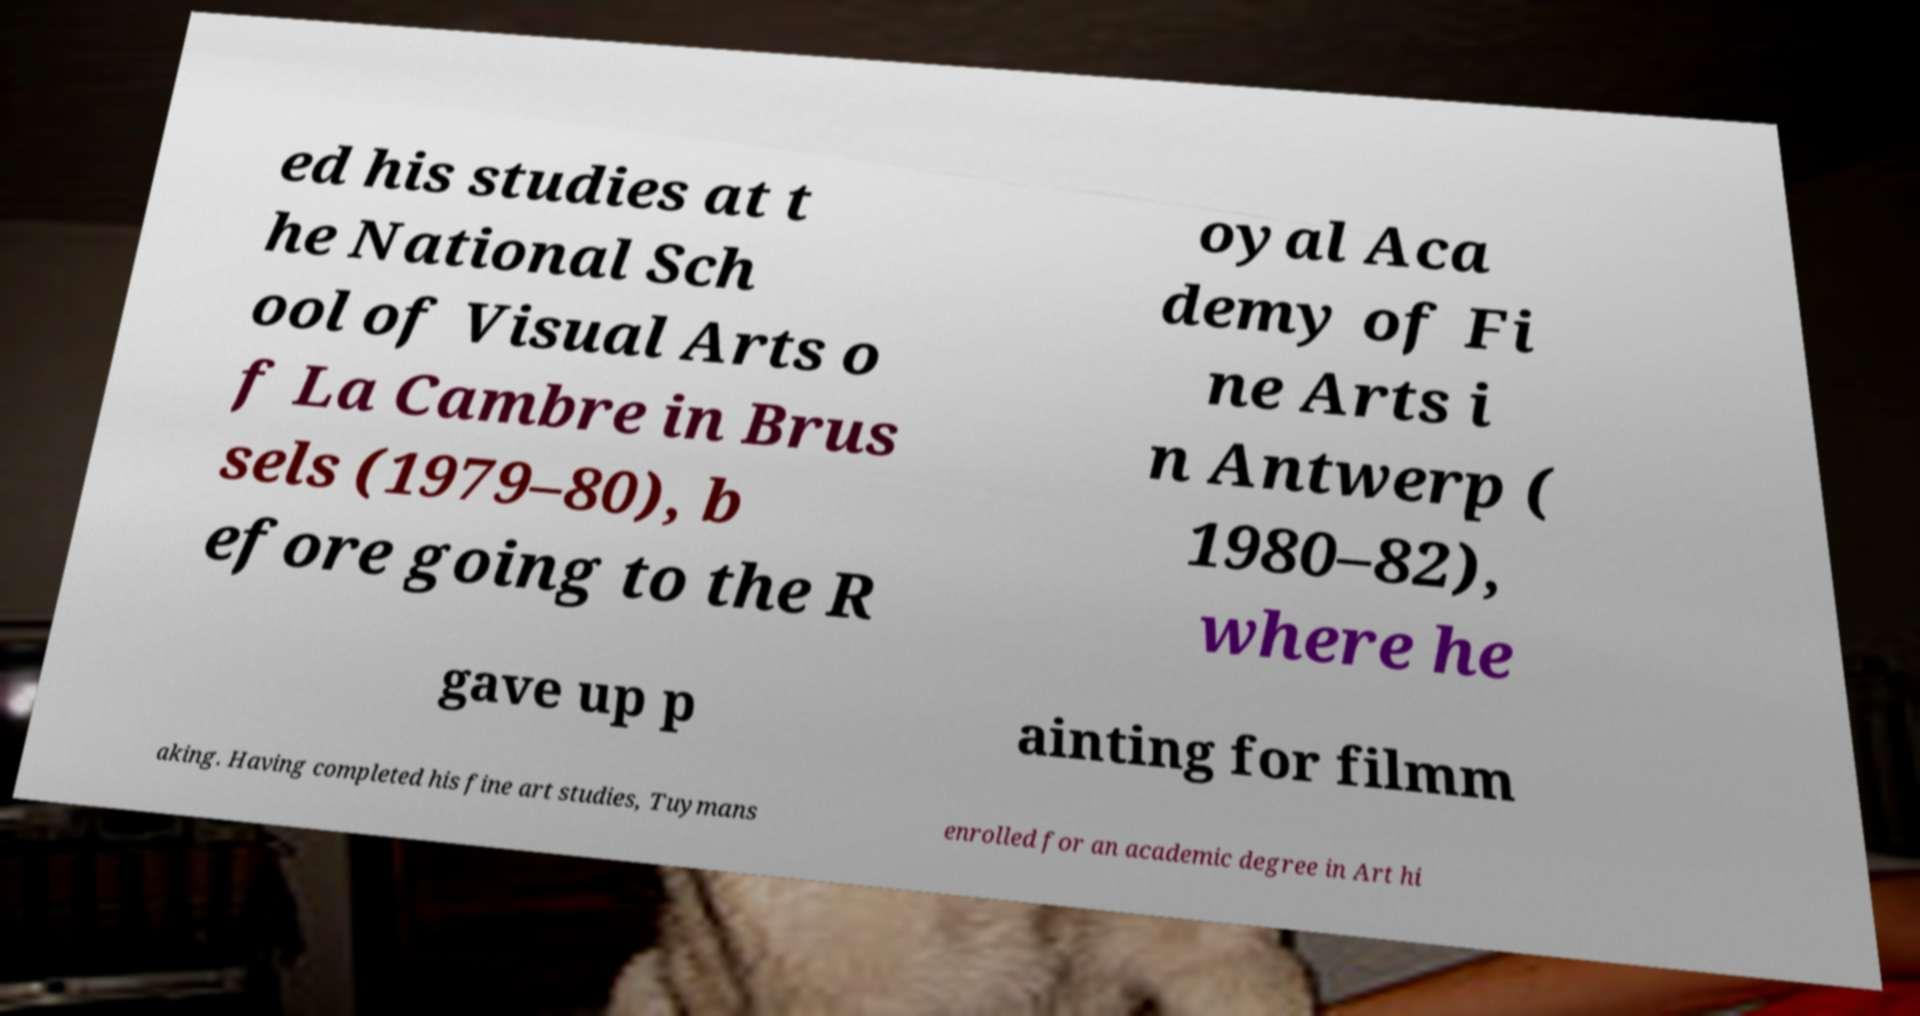What messages or text are displayed in this image? I need them in a readable, typed format. ed his studies at t he National Sch ool of Visual Arts o f La Cambre in Brus sels (1979–80), b efore going to the R oyal Aca demy of Fi ne Arts i n Antwerp ( 1980–82), where he gave up p ainting for filmm aking. Having completed his fine art studies, Tuymans enrolled for an academic degree in Art hi 